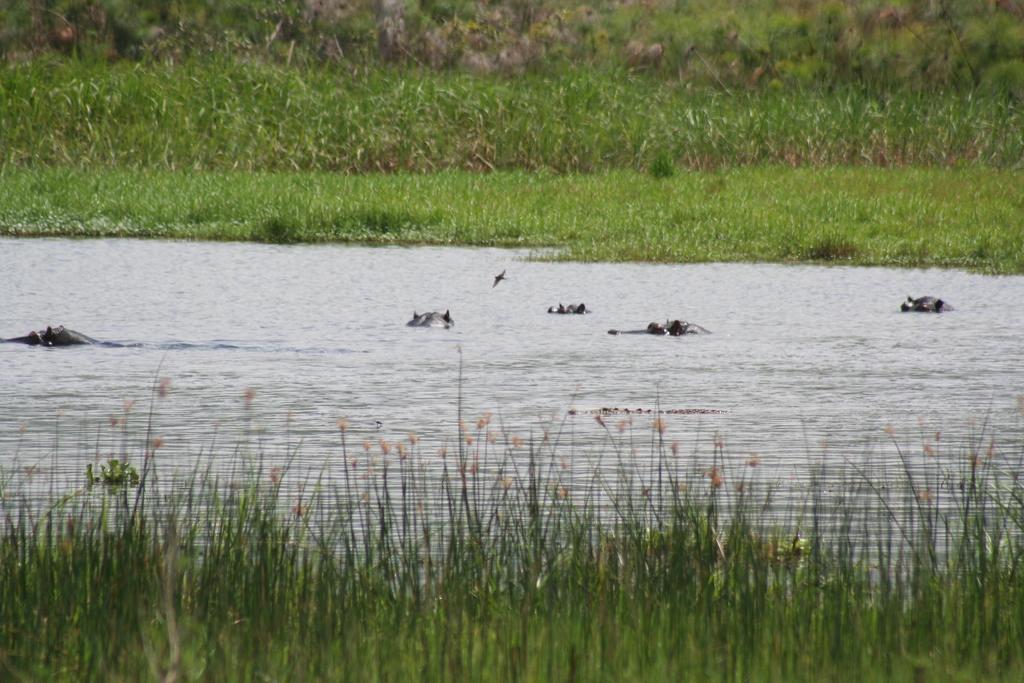Could you give a brief overview of what you see in this image? In the image we can see there are animals swimming in the water and there are plants on the ground. Behind the ground is covered with grass. 